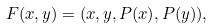Convert formula to latex. <formula><loc_0><loc_0><loc_500><loc_500>F ( x , y ) = ( x , y , P ( x ) , P ( y ) ) ,</formula> 